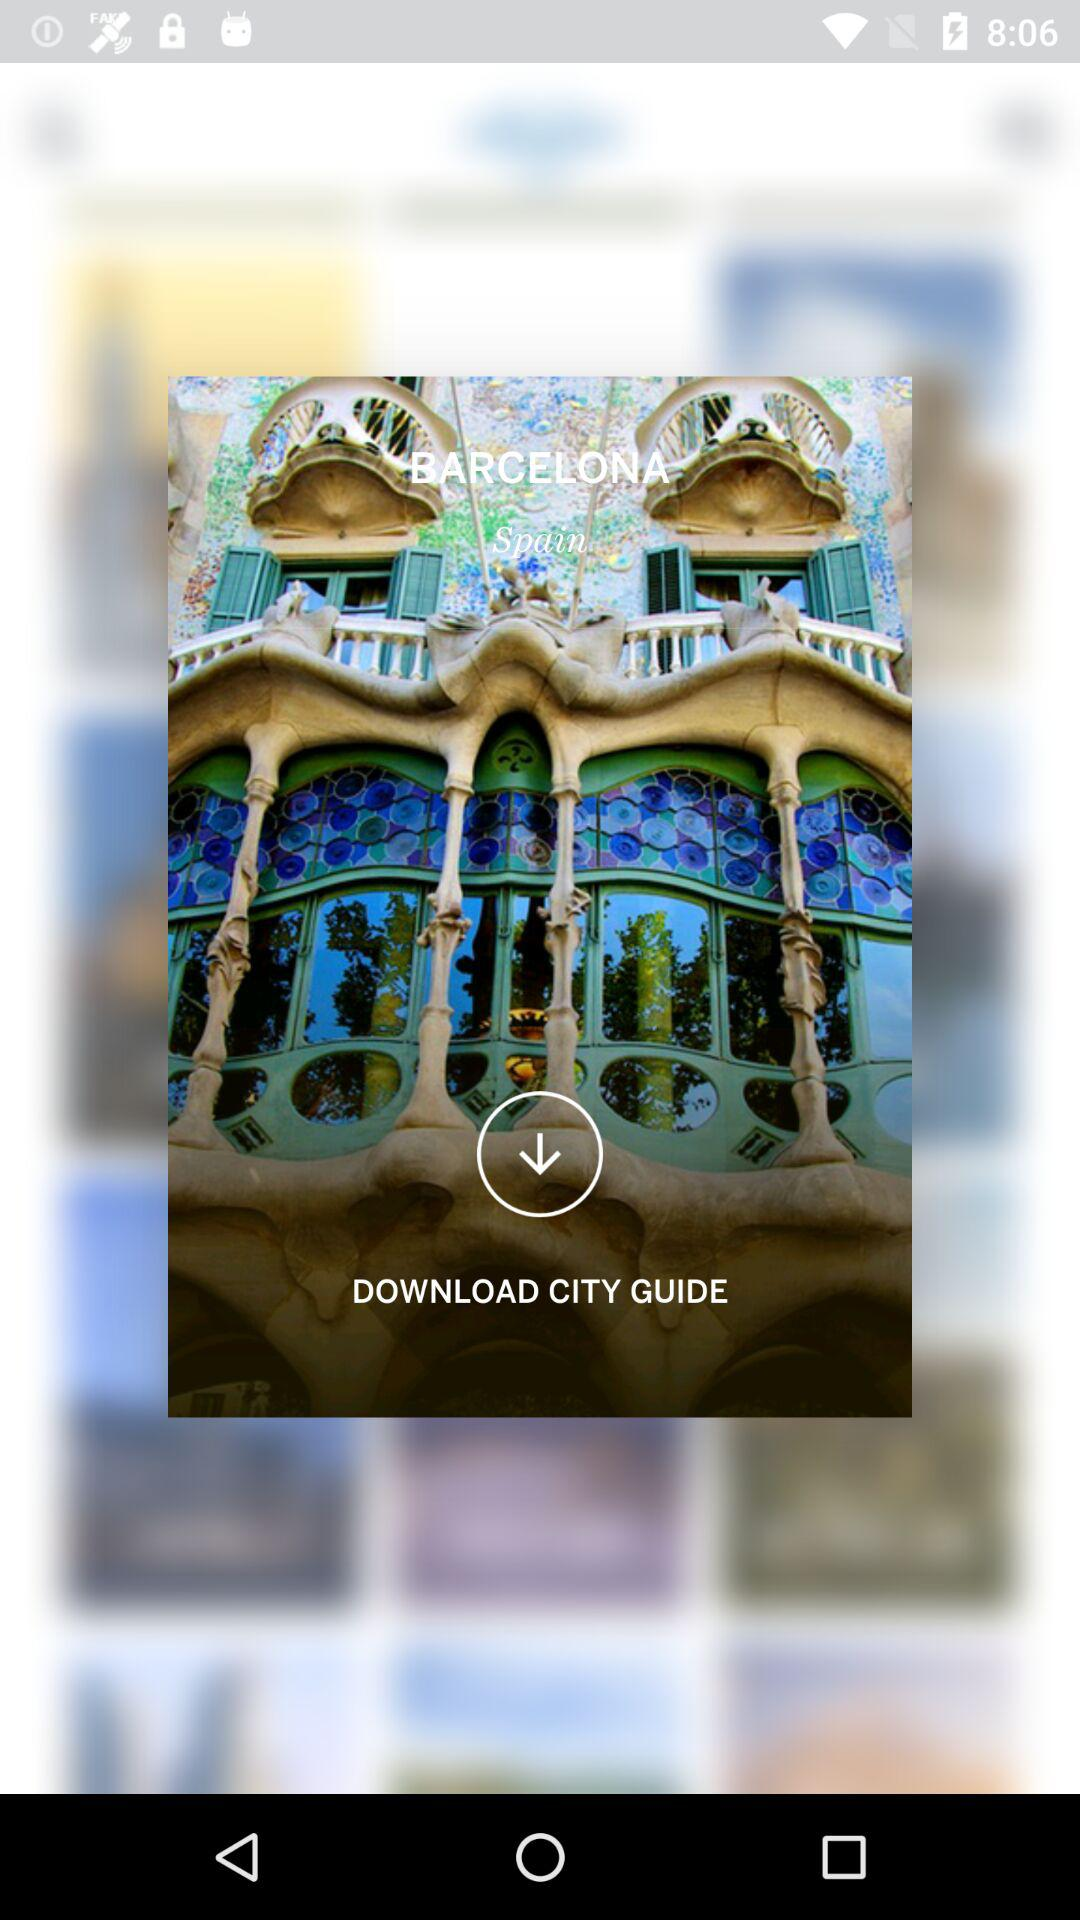What is the country name? The country name is Spain. 